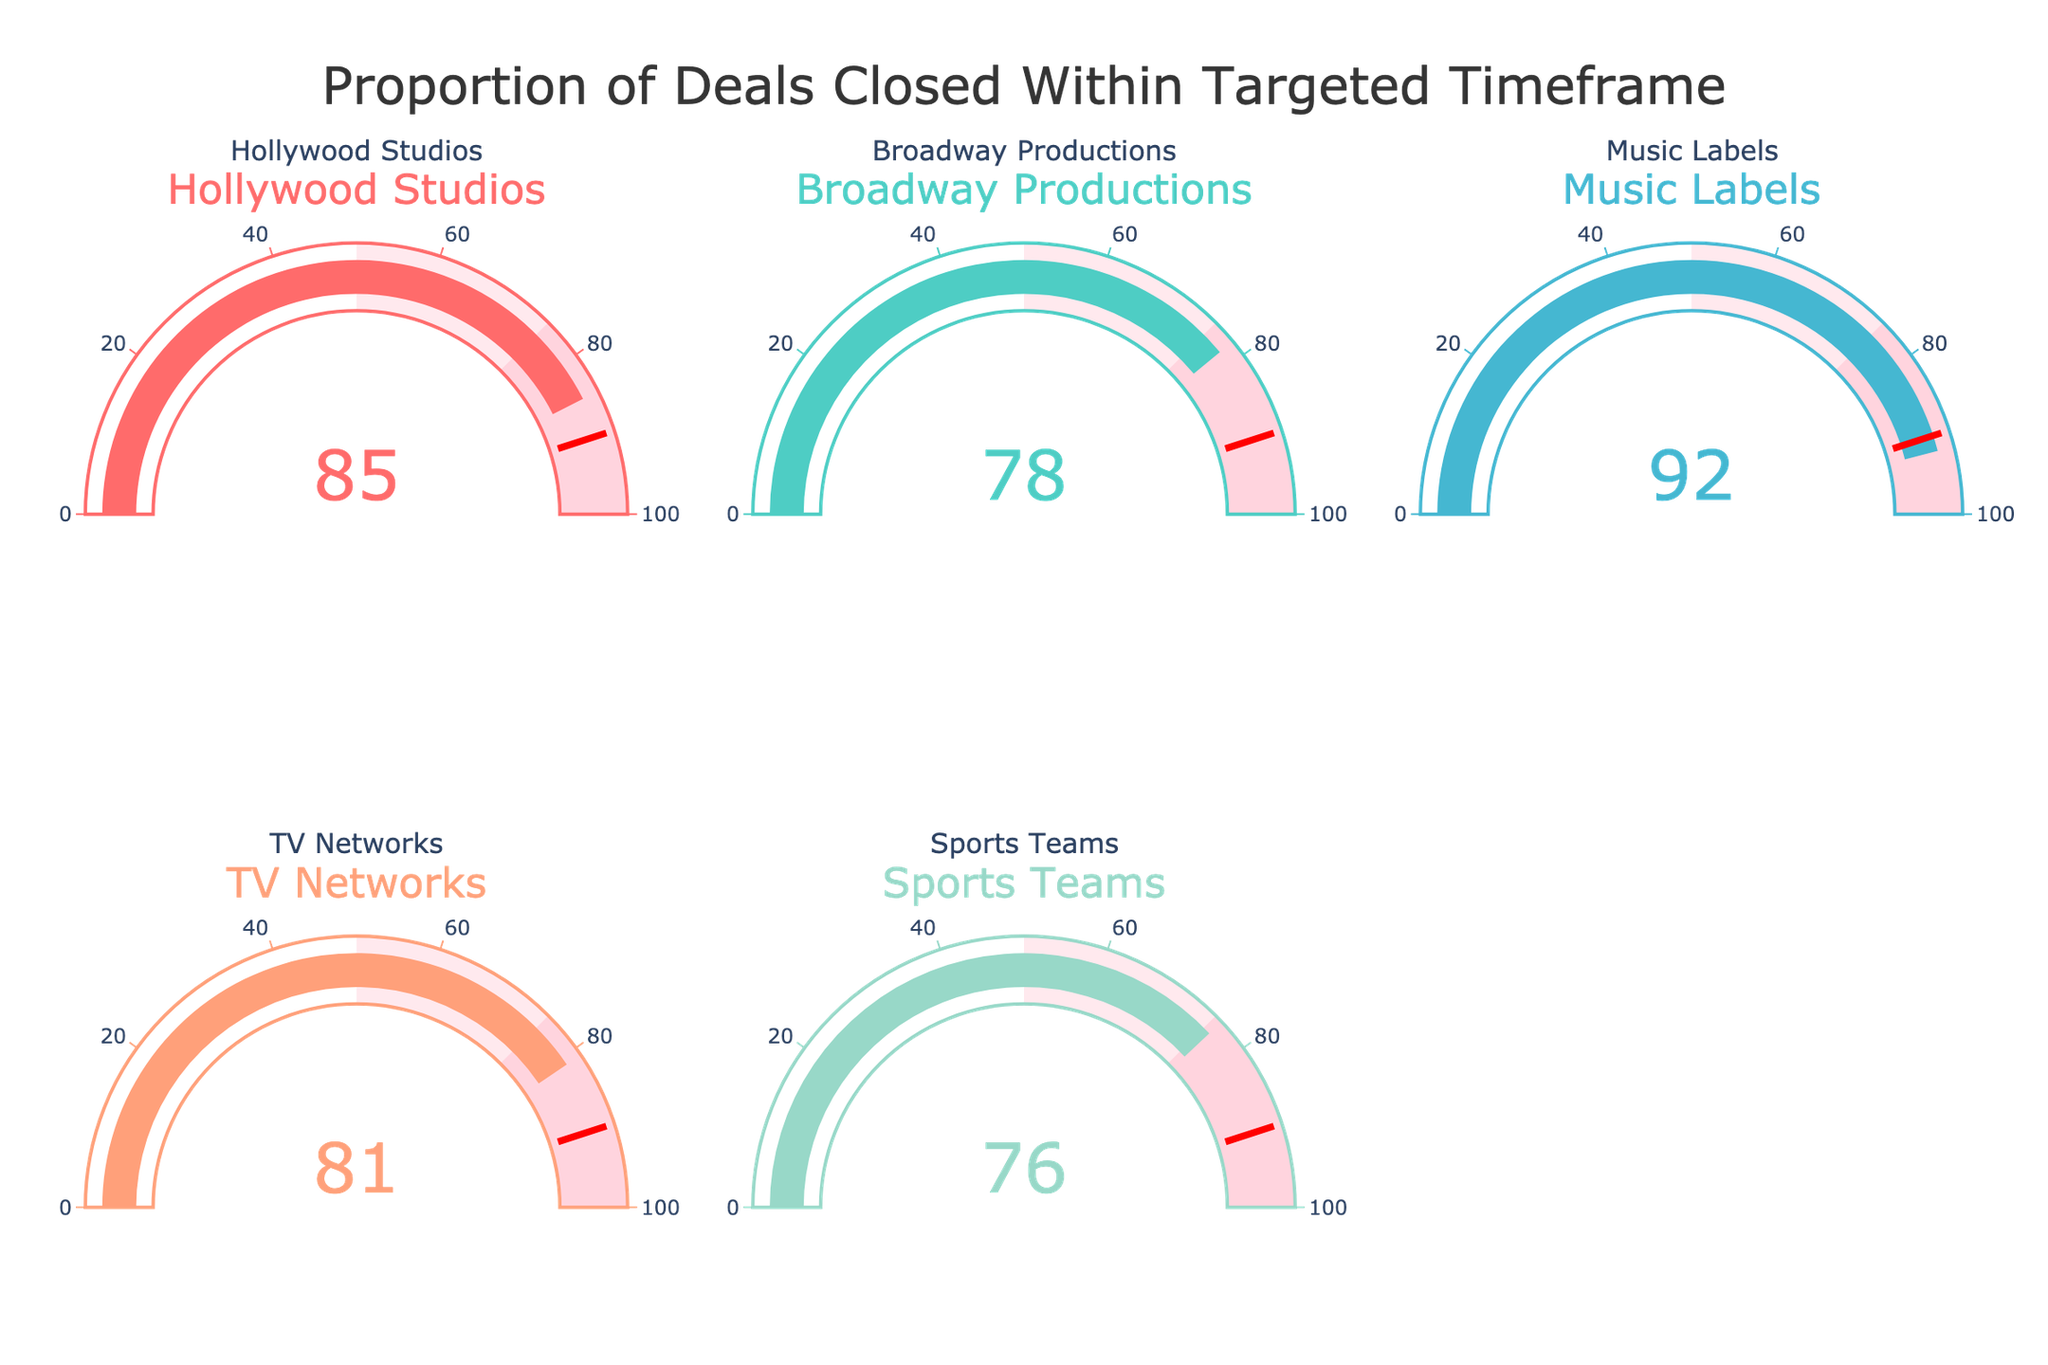what is the proportion of deals closed within the targeted timeframe for Hollywood Studios? The gauge for Hollywood Studios shows a value of 85%, indicating that 85% of deals were closed within the targeted timeframe.
Answer: 85% what is the lowest proportion shown in the gauges? Comparing the gauge values, Sports Teams has the lowest proportion at 76%.
Answer: 76% which category has the highest proportion of deals closed within the targeted timeframe? The Music Labels gauge shows the highest proportion with a value of 92%.
Answer: Music Labels what is the average proportion of deals closed within the targeted timeframe across all categories? Sum all values (0.85 + 0.78 + 0.92 + 0.81 + 0.76) to get 4.12, then divide by the number of categories (5), which gives 0.824 or 82.4%.
Answer: 82.4% which categories have a proportion of deals closed within the targeted timeframe greater than 80%? Categories with gauge values over 80% are Hollywood Studios (85%), Music Labels (92%), and TV Networks (81%).
Answer: Hollywood Studios, Music Labels, TV Networks by how much does the Music Labels' gauge exceed the Sports Teams' gauge? Subtract the proportion for Sports Teams (76%) from the proportion for Music Labels (92%), resulting in 92% - 76% = 16%.
Answer: 16% is there any category with a gauge value exactly equal to the threshold (90%)? All the gauges are checked, and none show a value of exactly 90%.
Answer: No how do the proportions for Broadway Productions and TV Networks compare? Broadway Productions has a gauge value of 78%, and TV Networks has a gauge value of 81%. Thus, TV Networks has a higher proportion by 3%.
Answer: TV Networks higher by 3% if the target proportion is 90%, which categories meet or exceed this threshold? From the gauges, only Music Labels meet or exceed the threshold of 90%, showing a value of 92%.
Answer: Music Labels 